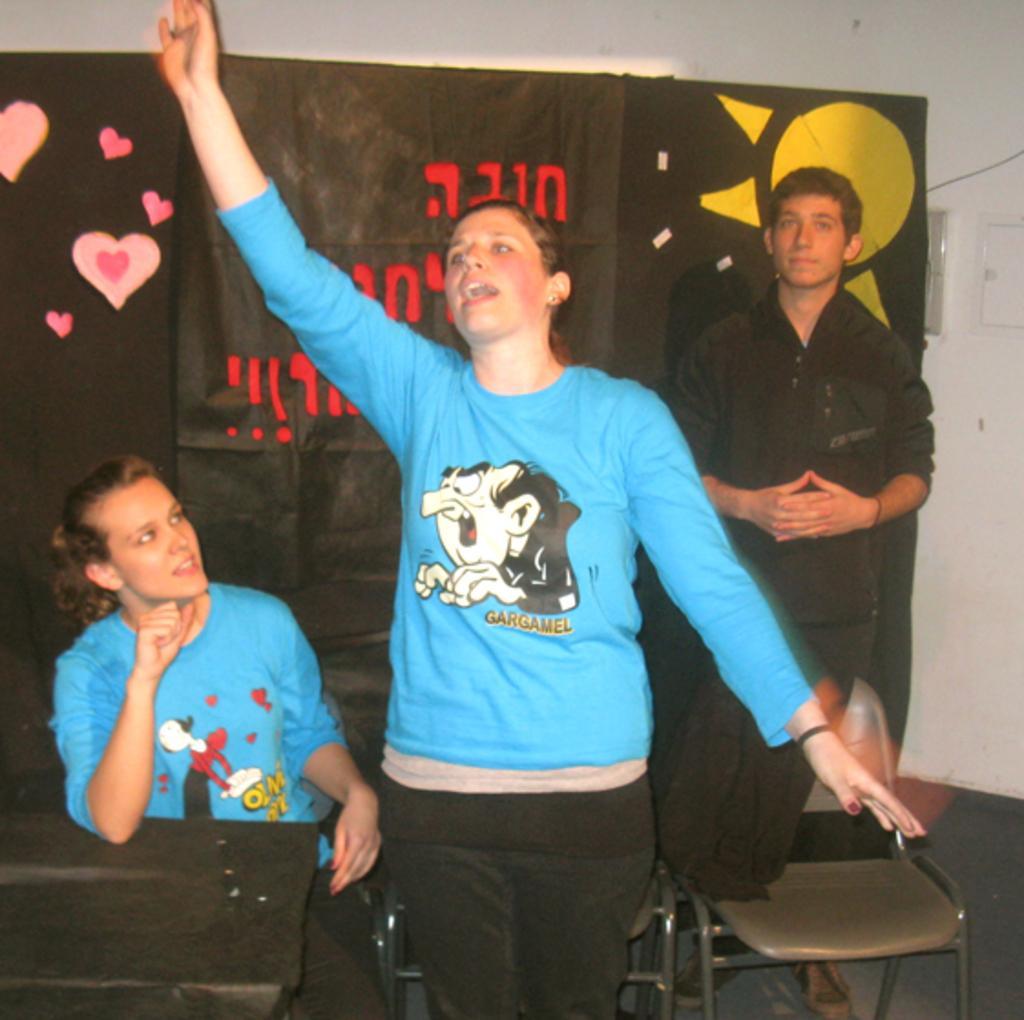Could you give a brief overview of what you see in this image? As we can see in the image there is a white color wall, black color banner, three people over here. The women on left side is wearing sky blue color shirt and sitting and on the right side there is a chair. 